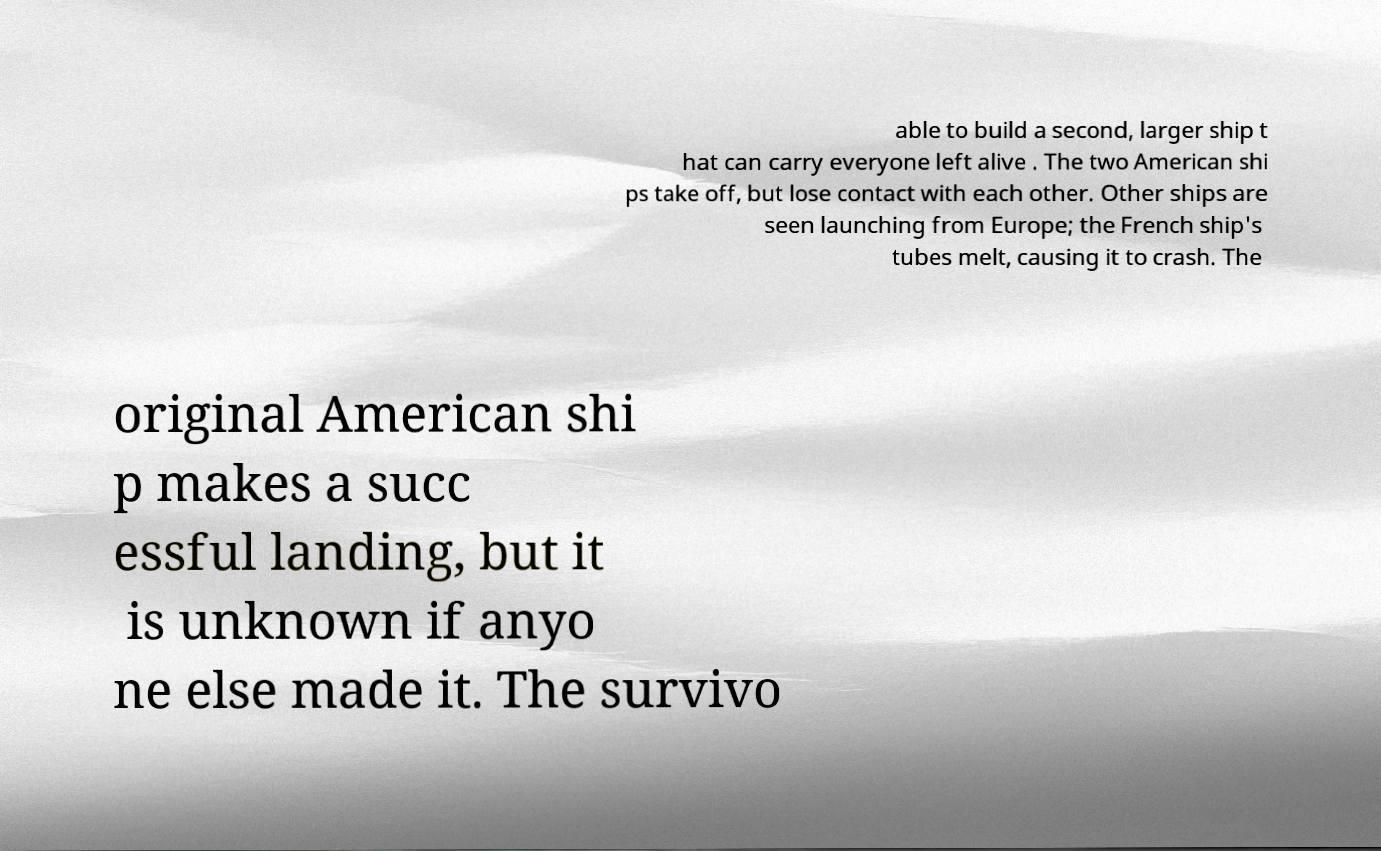What messages or text are displayed in this image? I need them in a readable, typed format. able to build a second, larger ship t hat can carry everyone left alive . The two American shi ps take off, but lose contact with each other. Other ships are seen launching from Europe; the French ship's tubes melt, causing it to crash. The original American shi p makes a succ essful landing, but it is unknown if anyo ne else made it. The survivo 